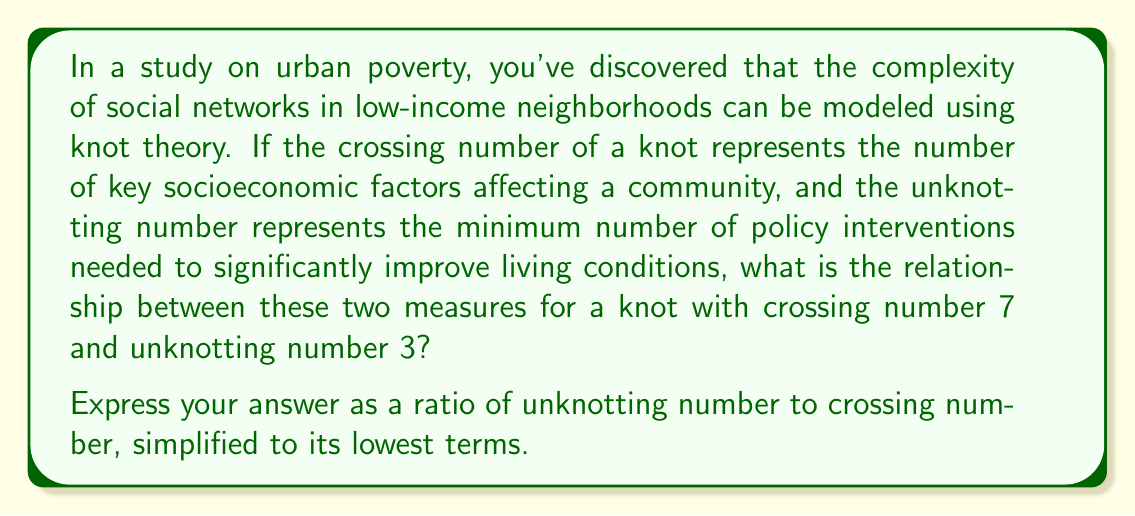Could you help me with this problem? To solve this problem, we need to understand the relationship between the crossing number and the unknotting number in knot theory, and how they relate to the given scenario of urban poverty.

1. Crossing number:
   - In this context, it represents the number of key socioeconomic factors affecting a community.
   - Given: Crossing number = 7

2. Unknotting number:
   - Here, it represents the minimum number of policy interventions needed to significantly improve living conditions.
   - Given: Unknotting number = 3

3. Relationship:
   - We need to express the relationship as a ratio of unknotting number to crossing number.
   - Ratio = Unknotting number : Crossing number
   - Ratio = 3 : 7

4. Simplify the ratio:
   - The ratio 3:7 is already in its lowest terms, as 3 and 7 are coprime (their greatest common divisor is 1).

Therefore, the relationship between the unknotting number and crossing number can be expressed as the ratio 3:7, which represents the proportion of necessary policy interventions to the total number of key socioeconomic factors affecting the community.
Answer: $\frac{3}{7}$ 